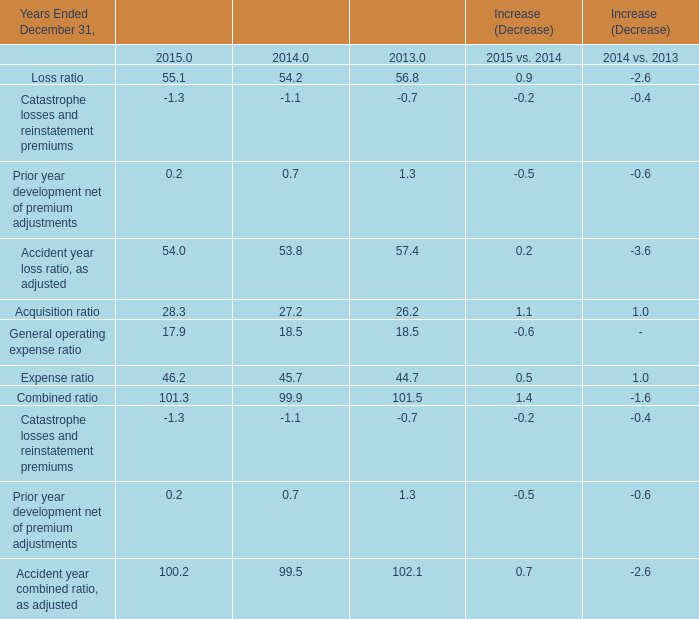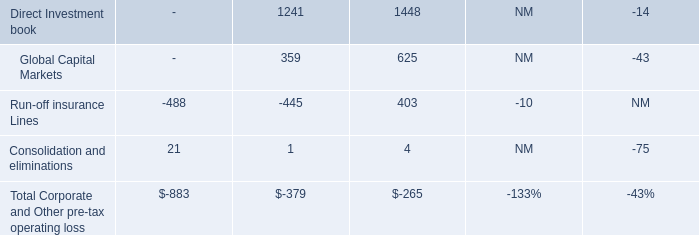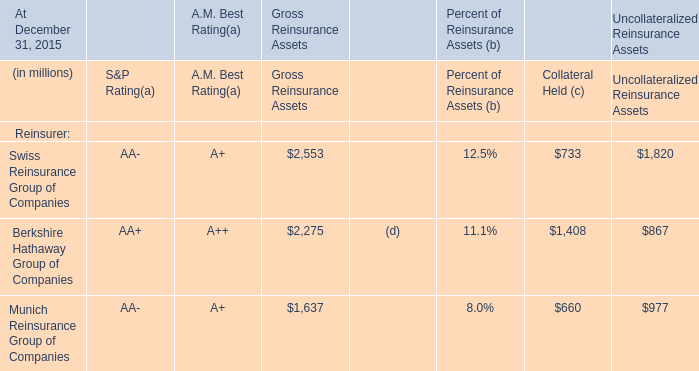What's the growth rate of Loss ratio in 2015? (in %) 
Computations: ((55.1 - 54.2) / 54.2)
Answer: 0.01661. 